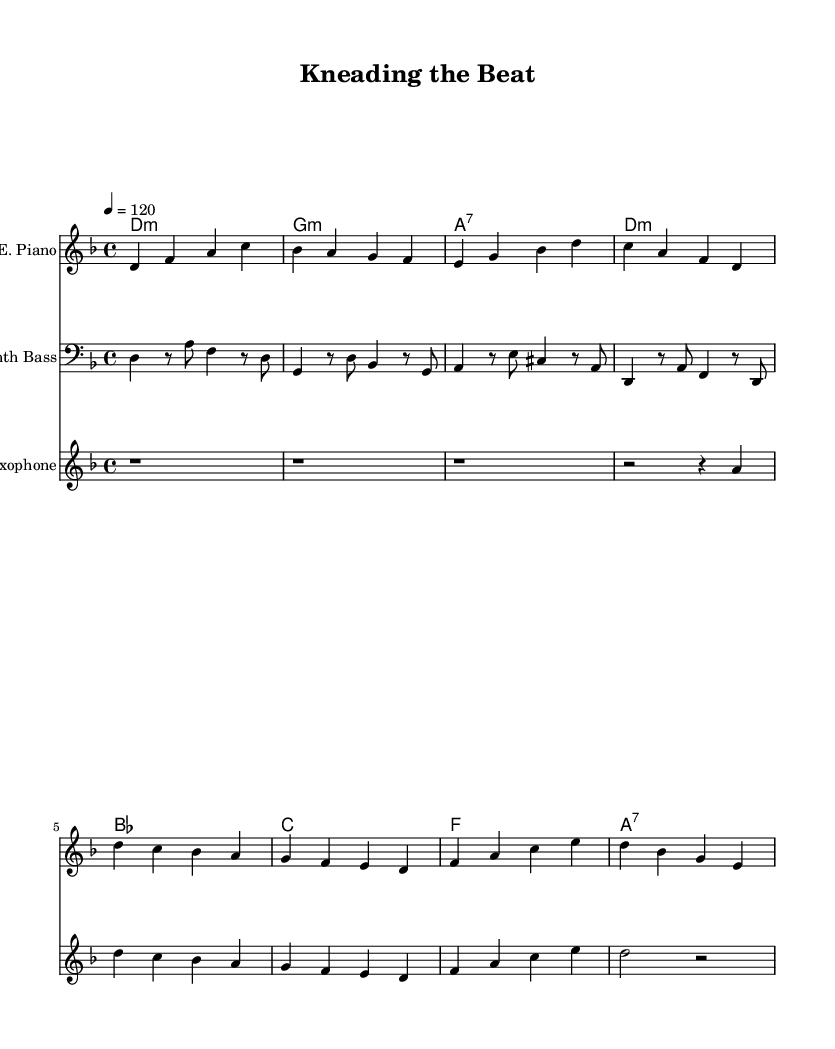What is the key signature of this music? The key signature is D minor, which has one flat (B flat). By observing the clef and the key signature indicated at the beginning of the score, we can determine the key.
Answer: D minor What is the time signature of this music? The time signature is 4/4, which means there are four beats in a measure and a quarter note gets one beat. This is shown right after the key signature at the beginning of the score.
Answer: 4/4 What is the tempo marking of the piece? The tempo marking is 120 beats per minute, indicated as "4 = 120" at the beginning of the score. This tells us how fast the piece should be played.
Answer: 120 What instrument plays the main melody? The electric piano plays the main melody throughout the score, as it is the first staff listed and has the most prominent notes.
Answer: Electric piano How many measures are there in the score? There are eight measures total. This can be counted by looking at the bar lines which separate the measures throughout the music.
Answer: Eight What kind of harmony is shown with the chord names? The harmony consists of minor and seventh chords, which can be determined by analyzing the chord names listed above the staves.
Answer: Minor and seventh chords What is the texture of the music based on the instrumentation? The texture is layered, as it combines multiple instruments like electric piano, synth bass, and saxophone. Each instrument adds a different musical element to the overall sound.
Answer: Layered 